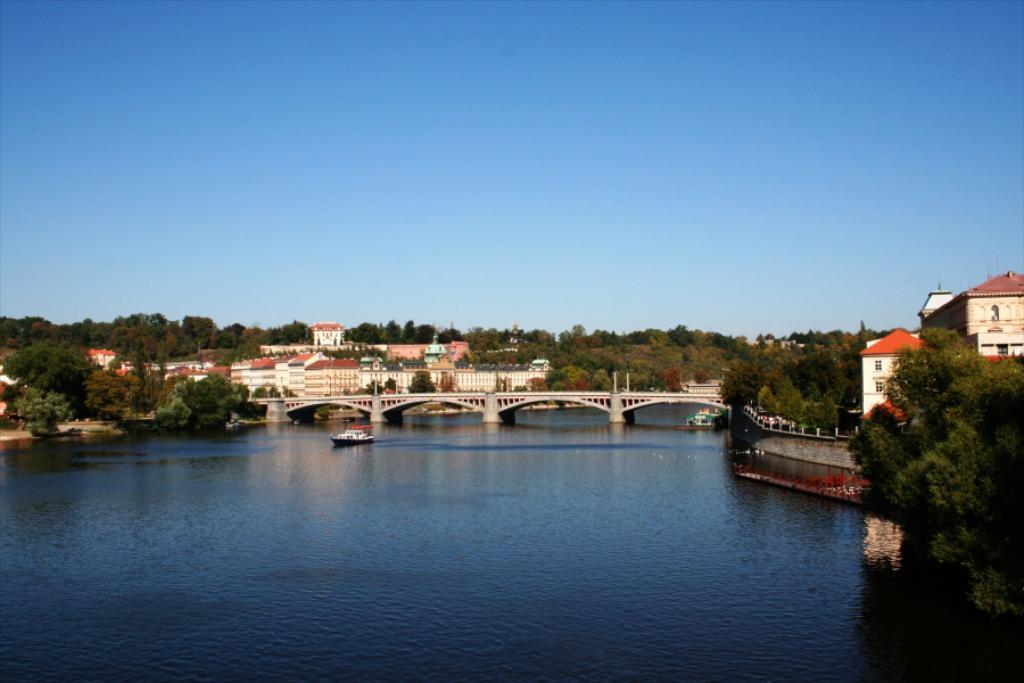How would you summarize this image in a sentence or two? In this image, we can see some trees and buildings. There is a bridge in the middle of the image. There is a boat floating on the water. There is a sky at the top of the image. 